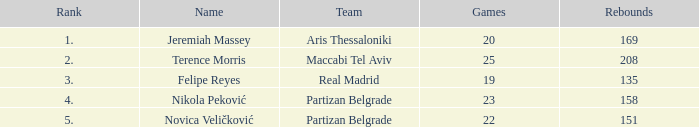How many games has the maccabi tel aviv team played in which they had fewer than 208 rebounds? None. 